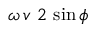Convert formula to latex. <formula><loc_0><loc_0><loc_500><loc_500>\omega \, v \ 2 \, \sin \phi</formula> 